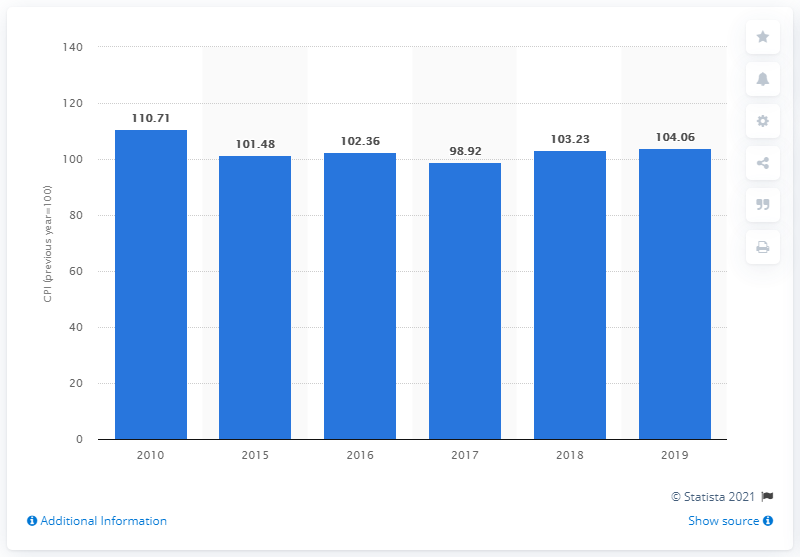Point out several critical features in this image. In 2019, the Consumer Price Index (CPI) for food and foodstuffs in Vietnam was 104.06. 